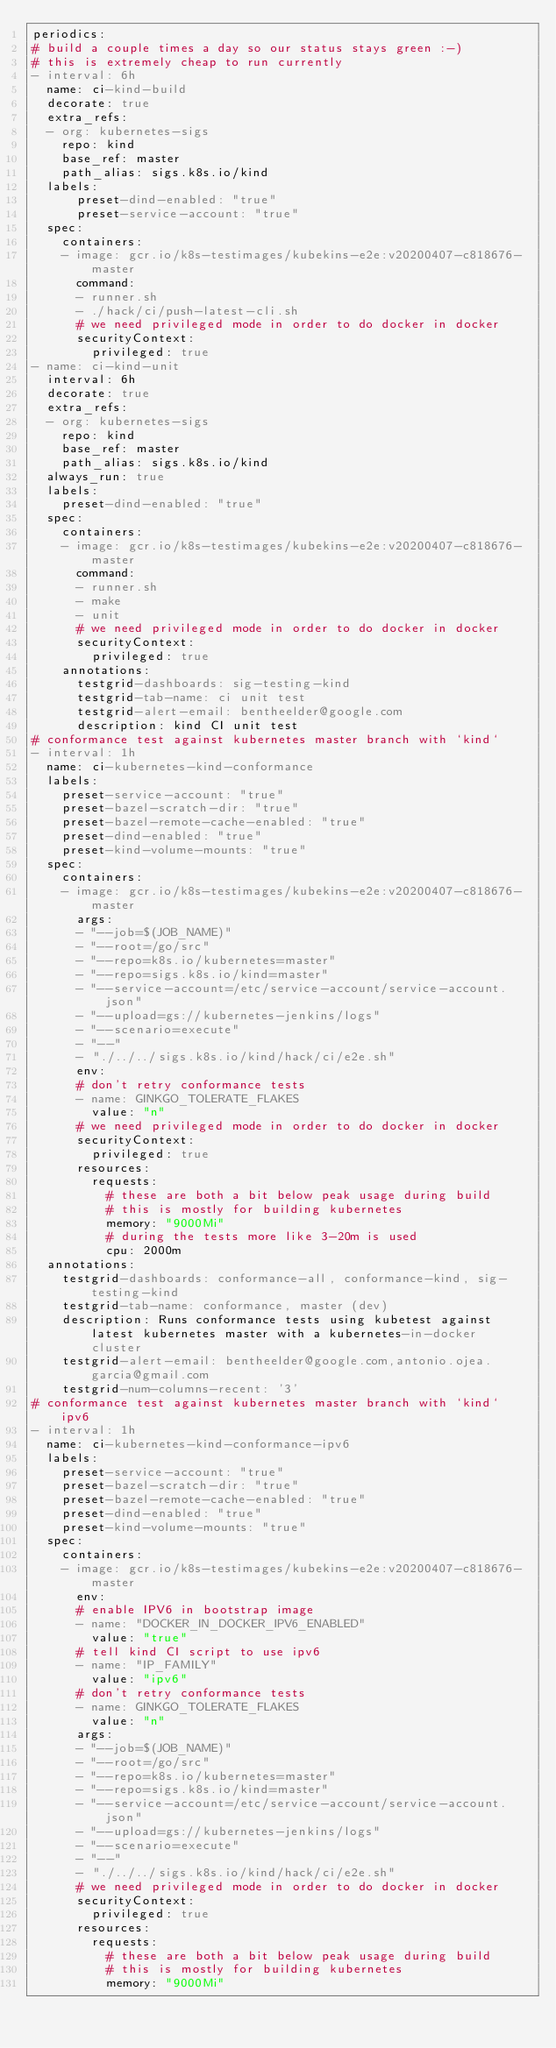Convert code to text. <code><loc_0><loc_0><loc_500><loc_500><_YAML_>periodics:
# build a couple times a day so our status stays green :-)
# this is extremely cheap to run currently
- interval: 6h
  name: ci-kind-build
  decorate: true
  extra_refs:
  - org: kubernetes-sigs
    repo: kind
    base_ref: master
    path_alias: sigs.k8s.io/kind
  labels:
      preset-dind-enabled: "true"
      preset-service-account: "true"
  spec:
    containers:
    - image: gcr.io/k8s-testimages/kubekins-e2e:v20200407-c818676-master
      command:
      - runner.sh
      - ./hack/ci/push-latest-cli.sh
      # we need privileged mode in order to do docker in docker
      securityContext:
        privileged: true
- name: ci-kind-unit
  interval: 6h
  decorate: true
  extra_refs:
  - org: kubernetes-sigs
    repo: kind
    base_ref: master
    path_alias: sigs.k8s.io/kind
  always_run: true
  labels:
    preset-dind-enabled: "true"
  spec:
    containers:
    - image: gcr.io/k8s-testimages/kubekins-e2e:v20200407-c818676-master
      command:
      - runner.sh
      - make
      - unit
      # we need privileged mode in order to do docker in docker
      securityContext:
        privileged: true
    annotations:
      testgrid-dashboards: sig-testing-kind
      testgrid-tab-name: ci unit test
      testgrid-alert-email: bentheelder@google.com
      description: kind CI unit test
# conformance test against kubernetes master branch with `kind`
- interval: 1h
  name: ci-kubernetes-kind-conformance
  labels:
    preset-service-account: "true"
    preset-bazel-scratch-dir: "true"
    preset-bazel-remote-cache-enabled: "true"
    preset-dind-enabled: "true"
    preset-kind-volume-mounts: "true"
  spec:
    containers:
    - image: gcr.io/k8s-testimages/kubekins-e2e:v20200407-c818676-master
      args:
      - "--job=$(JOB_NAME)"
      - "--root=/go/src"
      - "--repo=k8s.io/kubernetes=master"
      - "--repo=sigs.k8s.io/kind=master"
      - "--service-account=/etc/service-account/service-account.json"
      - "--upload=gs://kubernetes-jenkins/logs"
      - "--scenario=execute"
      - "--"
      - "./../../sigs.k8s.io/kind/hack/ci/e2e.sh"
      env:
      # don't retry conformance tests
      - name: GINKGO_TOLERATE_FLAKES
        value: "n"
      # we need privileged mode in order to do docker in docker
      securityContext:
        privileged: true
      resources:
        requests:
          # these are both a bit below peak usage during build
          # this is mostly for building kubernetes
          memory: "9000Mi"
          # during the tests more like 3-20m is used
          cpu: 2000m
  annotations:
    testgrid-dashboards: conformance-all, conformance-kind, sig-testing-kind
    testgrid-tab-name: conformance, master (dev)
    description: Runs conformance tests using kubetest against latest kubernetes master with a kubernetes-in-docker cluster
    testgrid-alert-email: bentheelder@google.com,antonio.ojea.garcia@gmail.com
    testgrid-num-columns-recent: '3'
# conformance test against kubernetes master branch with `kind` ipv6
- interval: 1h
  name: ci-kubernetes-kind-conformance-ipv6
  labels:
    preset-service-account: "true"
    preset-bazel-scratch-dir: "true"
    preset-bazel-remote-cache-enabled: "true"
    preset-dind-enabled: "true"
    preset-kind-volume-mounts: "true"
  spec:
    containers:
    - image: gcr.io/k8s-testimages/kubekins-e2e:v20200407-c818676-master
      env:
      # enable IPV6 in bootstrap image
      - name: "DOCKER_IN_DOCKER_IPV6_ENABLED"
        value: "true"
      # tell kind CI script to use ipv6
      - name: "IP_FAMILY"
        value: "ipv6"
      # don't retry conformance tests
      - name: GINKGO_TOLERATE_FLAKES
        value: "n"
      args:
      - "--job=$(JOB_NAME)"
      - "--root=/go/src"
      - "--repo=k8s.io/kubernetes=master"
      - "--repo=sigs.k8s.io/kind=master"
      - "--service-account=/etc/service-account/service-account.json"
      - "--upload=gs://kubernetes-jenkins/logs"
      - "--scenario=execute"
      - "--"
      - "./../../sigs.k8s.io/kind/hack/ci/e2e.sh"
      # we need privileged mode in order to do docker in docker
      securityContext:
        privileged: true
      resources:
        requests:
          # these are both a bit below peak usage during build
          # this is mostly for building kubernetes
          memory: "9000Mi"</code> 